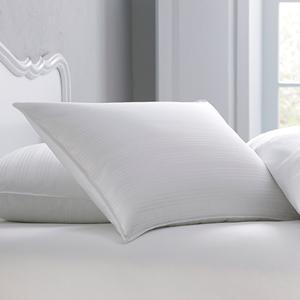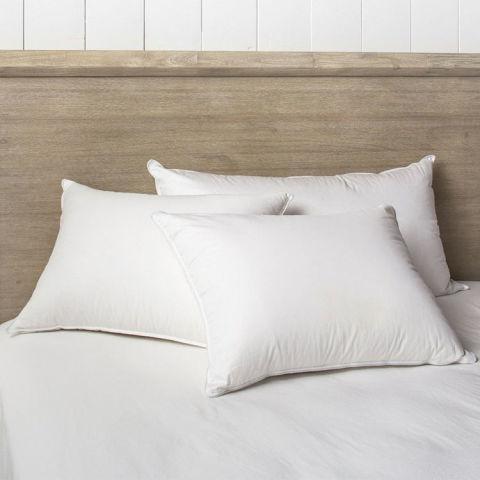The first image is the image on the left, the second image is the image on the right. For the images displayed, is the sentence "There are four white pillows on top of a white comforter." factually correct? Answer yes or no. No. The first image is the image on the left, the second image is the image on the right. Assess this claim about the two images: "The right image contains exactly three white pillows with smooth surfaces arranged overlapping but not stacked vertically.". Correct or not? Answer yes or no. Yes. 